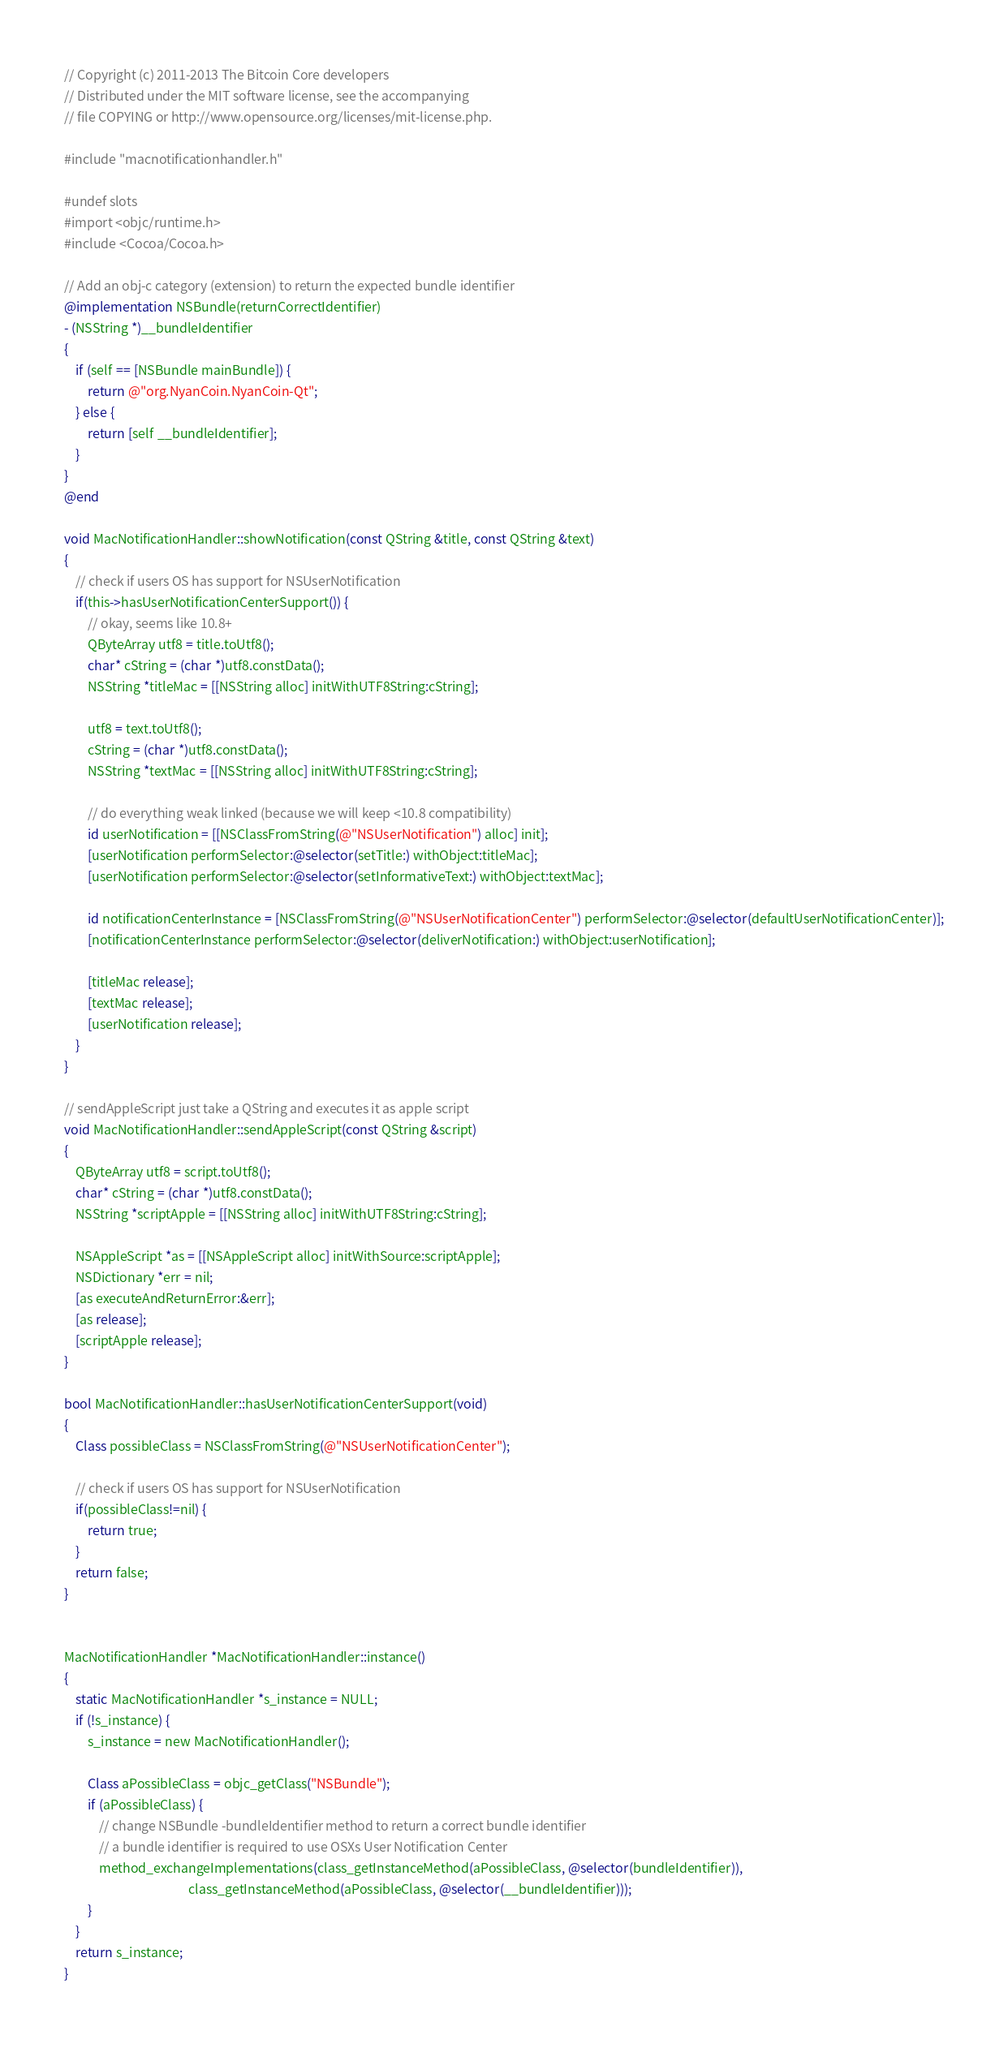Convert code to text. <code><loc_0><loc_0><loc_500><loc_500><_ObjectiveC_>// Copyright (c) 2011-2013 The Bitcoin Core developers
// Distributed under the MIT software license, see the accompanying
// file COPYING or http://www.opensource.org/licenses/mit-license.php.

#include "macnotificationhandler.h"

#undef slots
#import <objc/runtime.h>
#include <Cocoa/Cocoa.h>

// Add an obj-c category (extension) to return the expected bundle identifier
@implementation NSBundle(returnCorrectIdentifier)
- (NSString *)__bundleIdentifier
{
    if (self == [NSBundle mainBundle]) {
        return @"org.NyanCoin.NyanCoin-Qt";
    } else {
        return [self __bundleIdentifier];
    }
}
@end

void MacNotificationHandler::showNotification(const QString &title, const QString &text)
{
    // check if users OS has support for NSUserNotification
    if(this->hasUserNotificationCenterSupport()) {
        // okay, seems like 10.8+
        QByteArray utf8 = title.toUtf8();
        char* cString = (char *)utf8.constData();
        NSString *titleMac = [[NSString alloc] initWithUTF8String:cString];

        utf8 = text.toUtf8();
        cString = (char *)utf8.constData();
        NSString *textMac = [[NSString alloc] initWithUTF8String:cString];

        // do everything weak linked (because we will keep <10.8 compatibility)
        id userNotification = [[NSClassFromString(@"NSUserNotification") alloc] init];
        [userNotification performSelector:@selector(setTitle:) withObject:titleMac];
        [userNotification performSelector:@selector(setInformativeText:) withObject:textMac];

        id notificationCenterInstance = [NSClassFromString(@"NSUserNotificationCenter") performSelector:@selector(defaultUserNotificationCenter)];
        [notificationCenterInstance performSelector:@selector(deliverNotification:) withObject:userNotification];

        [titleMac release];
        [textMac release];
        [userNotification release];
    }
}

// sendAppleScript just take a QString and executes it as apple script
void MacNotificationHandler::sendAppleScript(const QString &script)
{
    QByteArray utf8 = script.toUtf8();
    char* cString = (char *)utf8.constData();
    NSString *scriptApple = [[NSString alloc] initWithUTF8String:cString];

    NSAppleScript *as = [[NSAppleScript alloc] initWithSource:scriptApple];
    NSDictionary *err = nil;
    [as executeAndReturnError:&err];
    [as release];
    [scriptApple release];
}

bool MacNotificationHandler::hasUserNotificationCenterSupport(void)
{
    Class possibleClass = NSClassFromString(@"NSUserNotificationCenter");

    // check if users OS has support for NSUserNotification
    if(possibleClass!=nil) {
        return true;
    }
    return false;
}


MacNotificationHandler *MacNotificationHandler::instance()
{
    static MacNotificationHandler *s_instance = NULL;
    if (!s_instance) {
        s_instance = new MacNotificationHandler();
        
        Class aPossibleClass = objc_getClass("NSBundle");
        if (aPossibleClass) {
            // change NSBundle -bundleIdentifier method to return a correct bundle identifier
            // a bundle identifier is required to use OSXs User Notification Center
            method_exchangeImplementations(class_getInstanceMethod(aPossibleClass, @selector(bundleIdentifier)),
                                           class_getInstanceMethod(aPossibleClass, @selector(__bundleIdentifier)));
        }
    }
    return s_instance;
}
</code> 